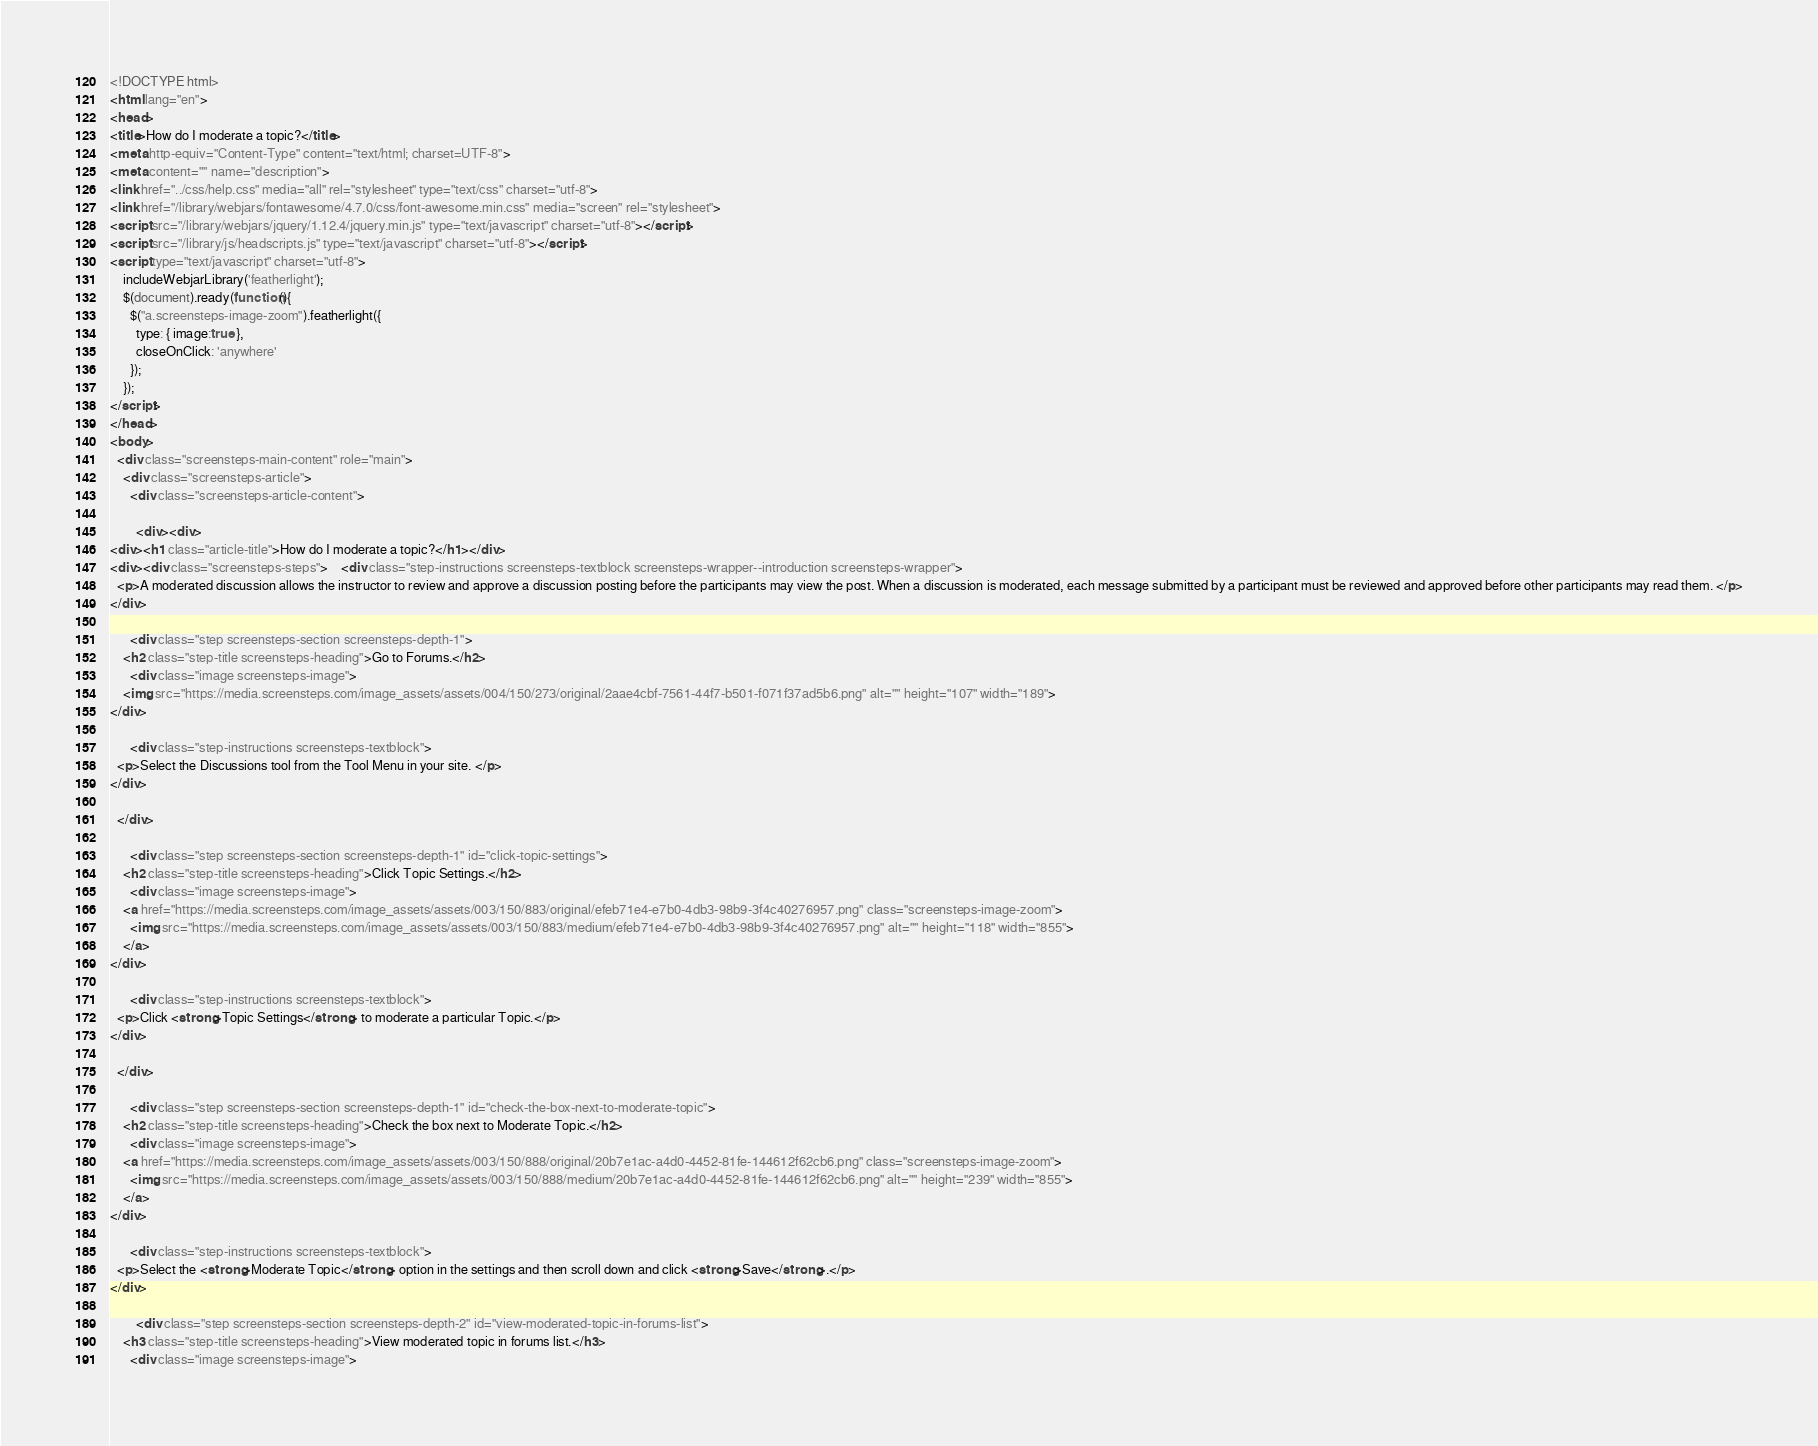<code> <loc_0><loc_0><loc_500><loc_500><_HTML_><!DOCTYPE html>
<html lang="en">
<head>
<title>How do I moderate a topic?</title>
<meta http-equiv="Content-Type" content="text/html; charset=UTF-8">
<meta content="" name="description">
<link href="../css/help.css" media="all" rel="stylesheet" type="text/css" charset="utf-8">
<link href="/library/webjars/fontawesome/4.7.0/css/font-awesome.min.css" media="screen" rel="stylesheet">
<script src="/library/webjars/jquery/1.12.4/jquery.min.js" type="text/javascript" charset="utf-8"></script>
<script src="/library/js/headscripts.js" type="text/javascript" charset="utf-8"></script>
<script type="text/javascript" charset="utf-8">
    includeWebjarLibrary('featherlight');
    $(document).ready(function(){
      $("a.screensteps-image-zoom").featherlight({
        type: { image:true },
        closeOnClick: 'anywhere'
      }); 
    });   
</script>
</head>
<body>
  <div class="screensteps-main-content" role="main">
    <div class="screensteps-article">
      <div class="screensteps-article-content">

        <div><div>
<div><h1 class="article-title">How do I moderate a topic?</h1></div>
<div><div class="screensteps-steps">    <div class="step-instructions screensteps-textblock screensteps-wrapper--introduction screensteps-wrapper">
  <p>A moderated discussion allows the instructor to review and approve a discussion posting before the participants may view the post. When a discussion is moderated, each message submitted by a participant must be reviewed and approved before other participants may read them. </p>
</div>

      <div class="step screensteps-section screensteps-depth-1">
    <h2 class="step-title screensteps-heading">Go to Forums.</h2>
      <div class="image screensteps-image">
    <img src="https://media.screensteps.com/image_assets/assets/004/150/273/original/2aae4cbf-7561-44f7-b501-f071f37ad5b6.png" alt="" height="107" width="189">
</div>
 
      <div class="step-instructions screensteps-textblock">
  <p>Select the Discussions tool from the Tool Menu in your site. </p>
</div>
 
  </div>

      <div class="step screensteps-section screensteps-depth-1" id="click-topic-settings">
    <h2 class="step-title screensteps-heading">Click Topic Settings.</h2>
      <div class="image screensteps-image">
    <a href="https://media.screensteps.com/image_assets/assets/003/150/883/original/efeb71e4-e7b0-4db3-98b9-3f4c40276957.png" class="screensteps-image-zoom">
      <img src="https://media.screensteps.com/image_assets/assets/003/150/883/medium/efeb71e4-e7b0-4db3-98b9-3f4c40276957.png" alt="" height="118" width="855">
    </a>
</div>
 
      <div class="step-instructions screensteps-textblock">
  <p>Click <strong>Topic Settings</strong> to moderate a particular Topic.</p>
</div>
 
  </div>

      <div class="step screensteps-section screensteps-depth-1" id="check-the-box-next-to-moderate-topic">
    <h2 class="step-title screensteps-heading">Check the box next to Moderate Topic.</h2>
      <div class="image screensteps-image">
    <a href="https://media.screensteps.com/image_assets/assets/003/150/888/original/20b7e1ac-a4d0-4452-81fe-144612f62cb6.png" class="screensteps-image-zoom">
      <img src="https://media.screensteps.com/image_assets/assets/003/150/888/medium/20b7e1ac-a4d0-4452-81fe-144612f62cb6.png" alt="" height="239" width="855">
    </a>
</div>
 
      <div class="step-instructions screensteps-textblock">
  <p>Select the <strong>Moderate Topic</strong> option in the settings and then scroll down and click <strong>Save</strong>.</p>
</div>
 
        <div class="step screensteps-section screensteps-depth-2" id="view-moderated-topic-in-forums-list">
    <h3 class="step-title screensteps-heading">View moderated topic in forums list.</h3>
      <div class="image screensteps-image"></code> 